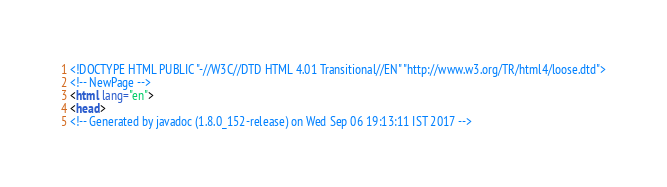<code> <loc_0><loc_0><loc_500><loc_500><_HTML_><!DOCTYPE HTML PUBLIC "-//W3C//DTD HTML 4.01 Transitional//EN" "http://www.w3.org/TR/html4/loose.dtd">
<!-- NewPage -->
<html lang="en">
<head>
<!-- Generated by javadoc (1.8.0_152-release) on Wed Sep 06 19:13:11 IST 2017 --></code> 